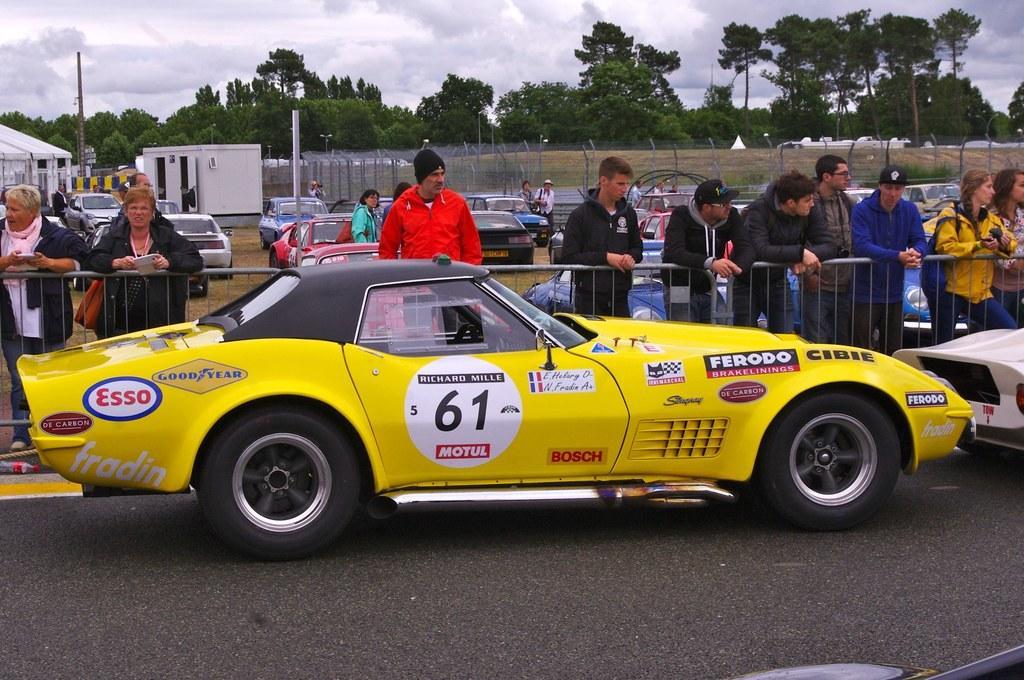How would you summarize this image in a sentence or two? In the image there are two cars on the road, behind the cars there is a fencing and there are many people standing behind the fencing and there are plenty of cars kept in the ground and there is a fencing around the ground, in the background there are a lot of trees. 